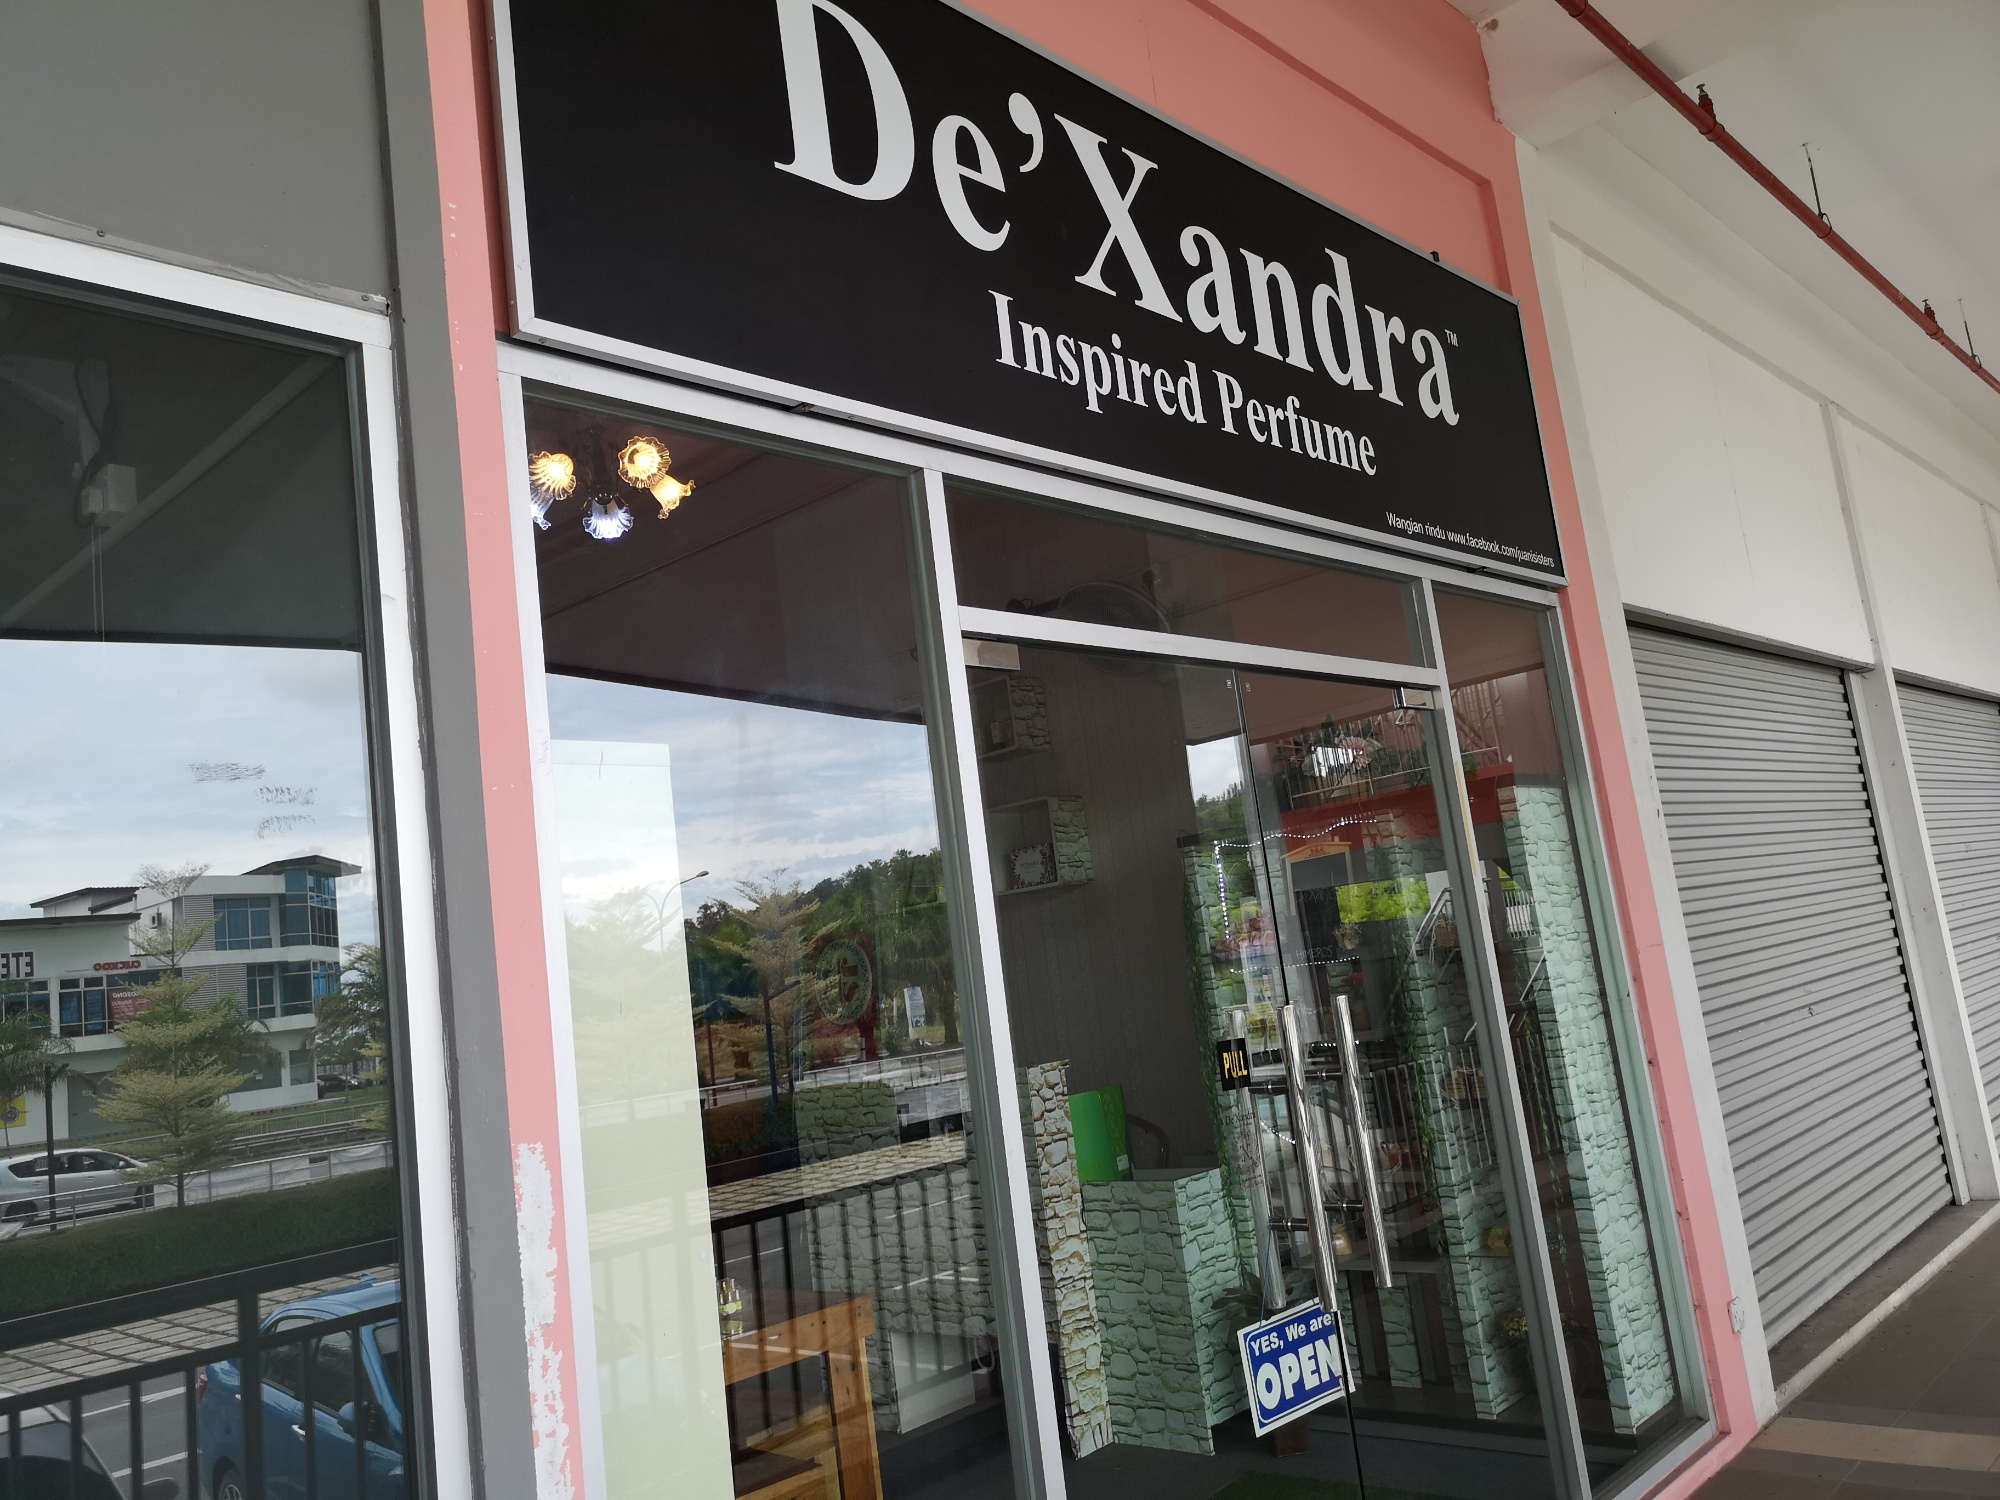Could you describe a day in the life of a De'Xandra's staff member working at this location? A day for a De'Xandra staff member might begin with unlocking the store and preparing the space for customers. They would ensure that the perfume bottles are perfectly arranged, clean the glass windows, and double-check that the 'OPEN' sign is visible. Throughout the day, they engage with customers, helping them find the perfect fragrance by offering sharegpt4v/samples and information about each product. Amid operation hours, they might also manage inventory, restock shelves, and process transactions. The staff's goal is to create a welcoming environment that enhances the customer's shopping experience. 